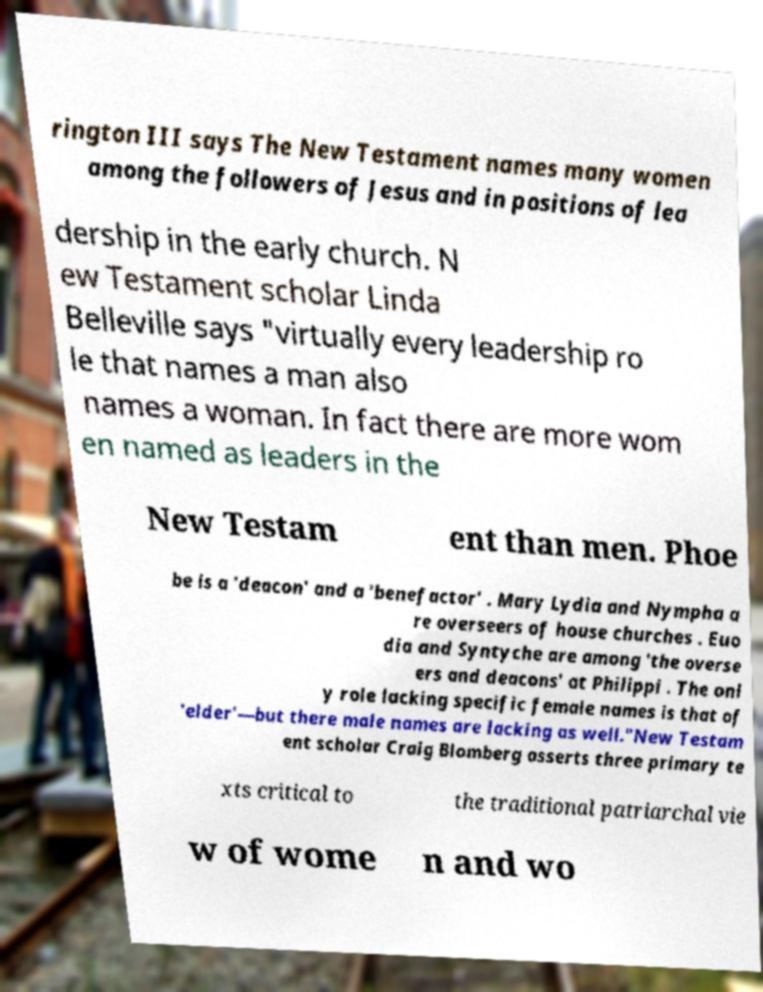There's text embedded in this image that I need extracted. Can you transcribe it verbatim? rington III says The New Testament names many women among the followers of Jesus and in positions of lea dership in the early church. N ew Testament scholar Linda Belleville says "virtually every leadership ro le that names a man also names a woman. In fact there are more wom en named as leaders in the New Testam ent than men. Phoe be is a 'deacon' and a 'benefactor' . Mary Lydia and Nympha a re overseers of house churches . Euo dia and Syntyche are among 'the overse ers and deacons' at Philippi . The onl y role lacking specific female names is that of 'elder'—but there male names are lacking as well."New Testam ent scholar Craig Blomberg asserts three primary te xts critical to the traditional patriarchal vie w of wome n and wo 